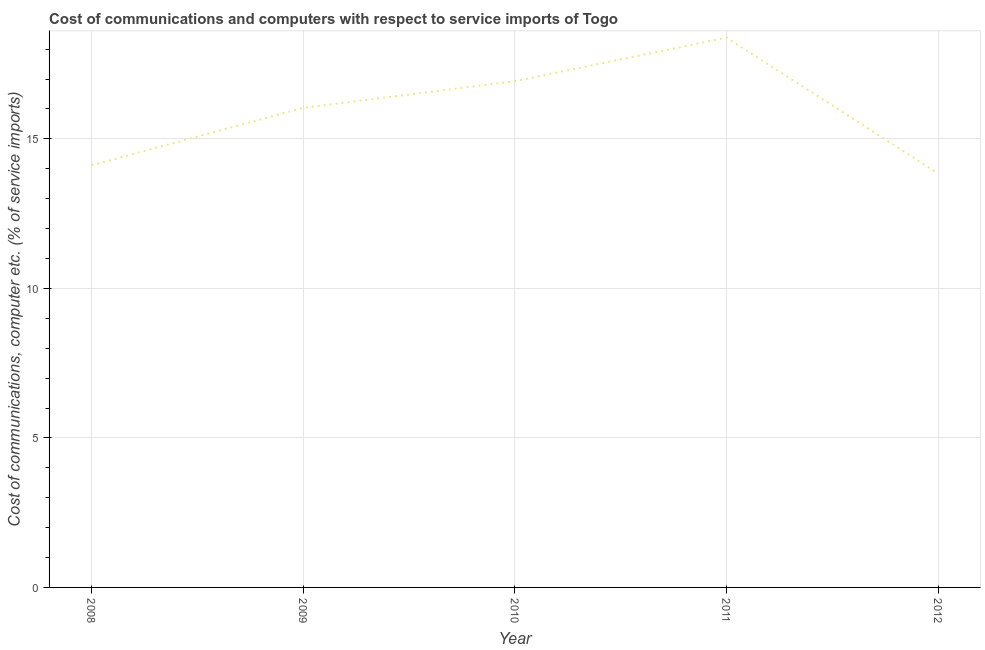What is the cost of communications and computer in 2008?
Offer a very short reply. 14.12. Across all years, what is the maximum cost of communications and computer?
Offer a terse response. 18.39. Across all years, what is the minimum cost of communications and computer?
Your response must be concise. 13.84. In which year was the cost of communications and computer minimum?
Ensure brevity in your answer.  2012. What is the sum of the cost of communications and computer?
Ensure brevity in your answer.  79.31. What is the difference between the cost of communications and computer in 2011 and 2012?
Your answer should be very brief. 4.54. What is the average cost of communications and computer per year?
Give a very brief answer. 15.86. What is the median cost of communications and computer?
Provide a succinct answer. 16.04. What is the ratio of the cost of communications and computer in 2009 to that in 2012?
Make the answer very short. 1.16. What is the difference between the highest and the second highest cost of communications and computer?
Your answer should be compact. 1.46. Is the sum of the cost of communications and computer in 2010 and 2011 greater than the maximum cost of communications and computer across all years?
Give a very brief answer. Yes. What is the difference between the highest and the lowest cost of communications and computer?
Provide a succinct answer. 4.54. Does the cost of communications and computer monotonically increase over the years?
Your answer should be compact. No. How many years are there in the graph?
Give a very brief answer. 5. Are the values on the major ticks of Y-axis written in scientific E-notation?
Give a very brief answer. No. Does the graph contain any zero values?
Keep it short and to the point. No. Does the graph contain grids?
Offer a terse response. Yes. What is the title of the graph?
Give a very brief answer. Cost of communications and computers with respect to service imports of Togo. What is the label or title of the Y-axis?
Provide a short and direct response. Cost of communications, computer etc. (% of service imports). What is the Cost of communications, computer etc. (% of service imports) in 2008?
Keep it short and to the point. 14.12. What is the Cost of communications, computer etc. (% of service imports) of 2009?
Provide a short and direct response. 16.04. What is the Cost of communications, computer etc. (% of service imports) in 2010?
Offer a very short reply. 16.93. What is the Cost of communications, computer etc. (% of service imports) in 2011?
Provide a succinct answer. 18.39. What is the Cost of communications, computer etc. (% of service imports) of 2012?
Make the answer very short. 13.84. What is the difference between the Cost of communications, computer etc. (% of service imports) in 2008 and 2009?
Offer a very short reply. -1.92. What is the difference between the Cost of communications, computer etc. (% of service imports) in 2008 and 2010?
Offer a very short reply. -2.81. What is the difference between the Cost of communications, computer etc. (% of service imports) in 2008 and 2011?
Provide a succinct answer. -4.27. What is the difference between the Cost of communications, computer etc. (% of service imports) in 2008 and 2012?
Provide a succinct answer. 0.27. What is the difference between the Cost of communications, computer etc. (% of service imports) in 2009 and 2010?
Ensure brevity in your answer.  -0.89. What is the difference between the Cost of communications, computer etc. (% of service imports) in 2009 and 2011?
Provide a succinct answer. -2.35. What is the difference between the Cost of communications, computer etc. (% of service imports) in 2009 and 2012?
Give a very brief answer. 2.19. What is the difference between the Cost of communications, computer etc. (% of service imports) in 2010 and 2011?
Give a very brief answer. -1.46. What is the difference between the Cost of communications, computer etc. (% of service imports) in 2010 and 2012?
Provide a short and direct response. 3.09. What is the difference between the Cost of communications, computer etc. (% of service imports) in 2011 and 2012?
Your answer should be compact. 4.54. What is the ratio of the Cost of communications, computer etc. (% of service imports) in 2008 to that in 2009?
Make the answer very short. 0.88. What is the ratio of the Cost of communications, computer etc. (% of service imports) in 2008 to that in 2010?
Provide a short and direct response. 0.83. What is the ratio of the Cost of communications, computer etc. (% of service imports) in 2008 to that in 2011?
Keep it short and to the point. 0.77. What is the ratio of the Cost of communications, computer etc. (% of service imports) in 2009 to that in 2010?
Ensure brevity in your answer.  0.95. What is the ratio of the Cost of communications, computer etc. (% of service imports) in 2009 to that in 2011?
Provide a short and direct response. 0.87. What is the ratio of the Cost of communications, computer etc. (% of service imports) in 2009 to that in 2012?
Make the answer very short. 1.16. What is the ratio of the Cost of communications, computer etc. (% of service imports) in 2010 to that in 2011?
Provide a short and direct response. 0.92. What is the ratio of the Cost of communications, computer etc. (% of service imports) in 2010 to that in 2012?
Your answer should be compact. 1.22. What is the ratio of the Cost of communications, computer etc. (% of service imports) in 2011 to that in 2012?
Offer a very short reply. 1.33. 